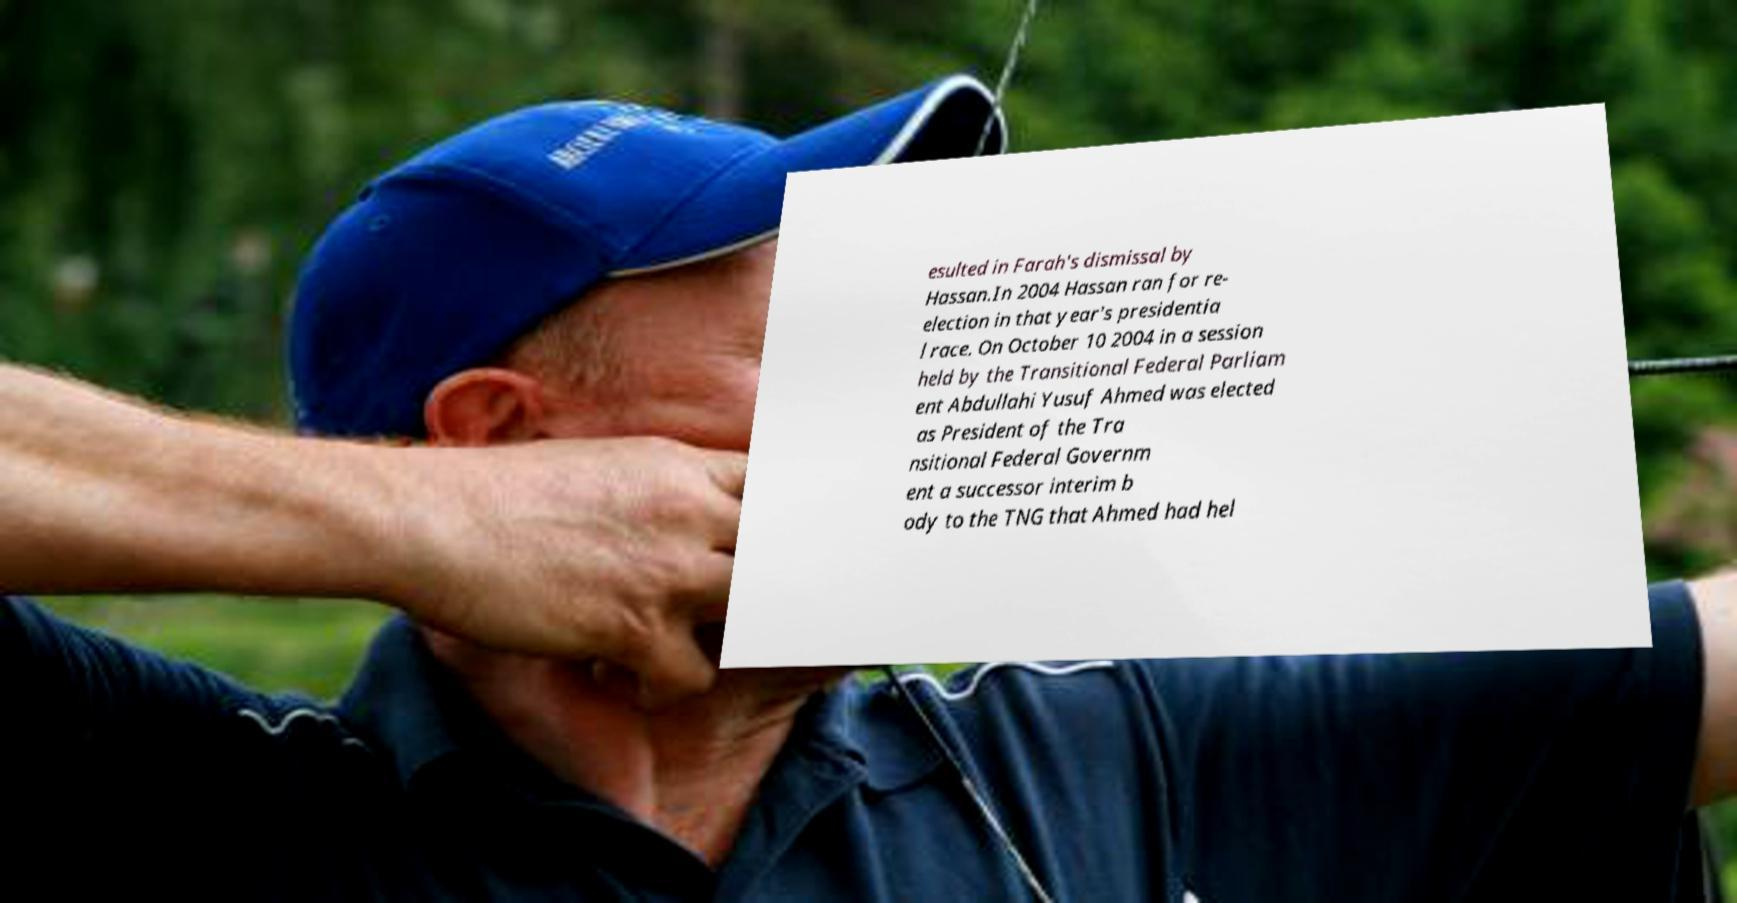I need the written content from this picture converted into text. Can you do that? esulted in Farah's dismissal by Hassan.In 2004 Hassan ran for re- election in that year's presidentia l race. On October 10 2004 in a session held by the Transitional Federal Parliam ent Abdullahi Yusuf Ahmed was elected as President of the Tra nsitional Federal Governm ent a successor interim b ody to the TNG that Ahmed had hel 